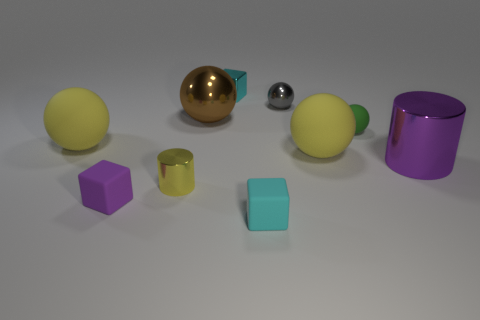Subtract all cyan shiny cubes. How many cubes are left? 2 Subtract all purple cubes. How many cubes are left? 2 Subtract all blocks. How many objects are left? 7 Add 6 gray metallic things. How many gray metallic things exist? 7 Subtract 0 yellow cubes. How many objects are left? 10 Subtract 3 spheres. How many spheres are left? 2 Subtract all cyan cylinders. Subtract all purple spheres. How many cylinders are left? 2 Subtract all purple spheres. How many purple blocks are left? 1 Subtract all small shiny cylinders. Subtract all matte balls. How many objects are left? 6 Add 1 purple cylinders. How many purple cylinders are left? 2 